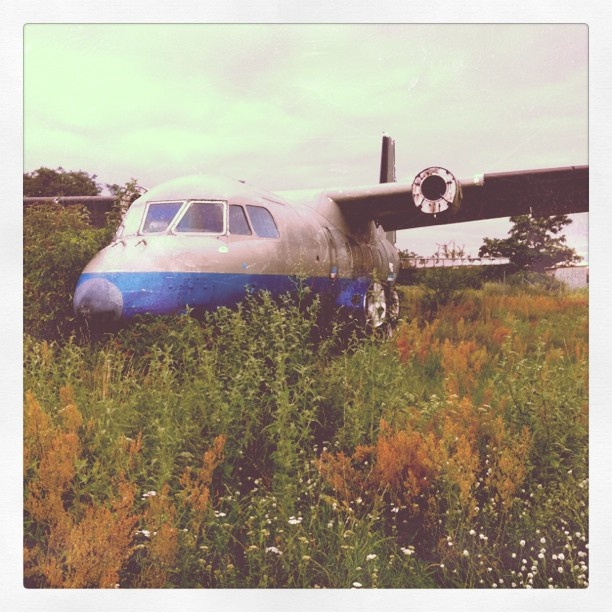Describe the objects in this image and their specific colors. I can see a airplane in white, lightgray, purple, gray, and darkgray tones in this image. 